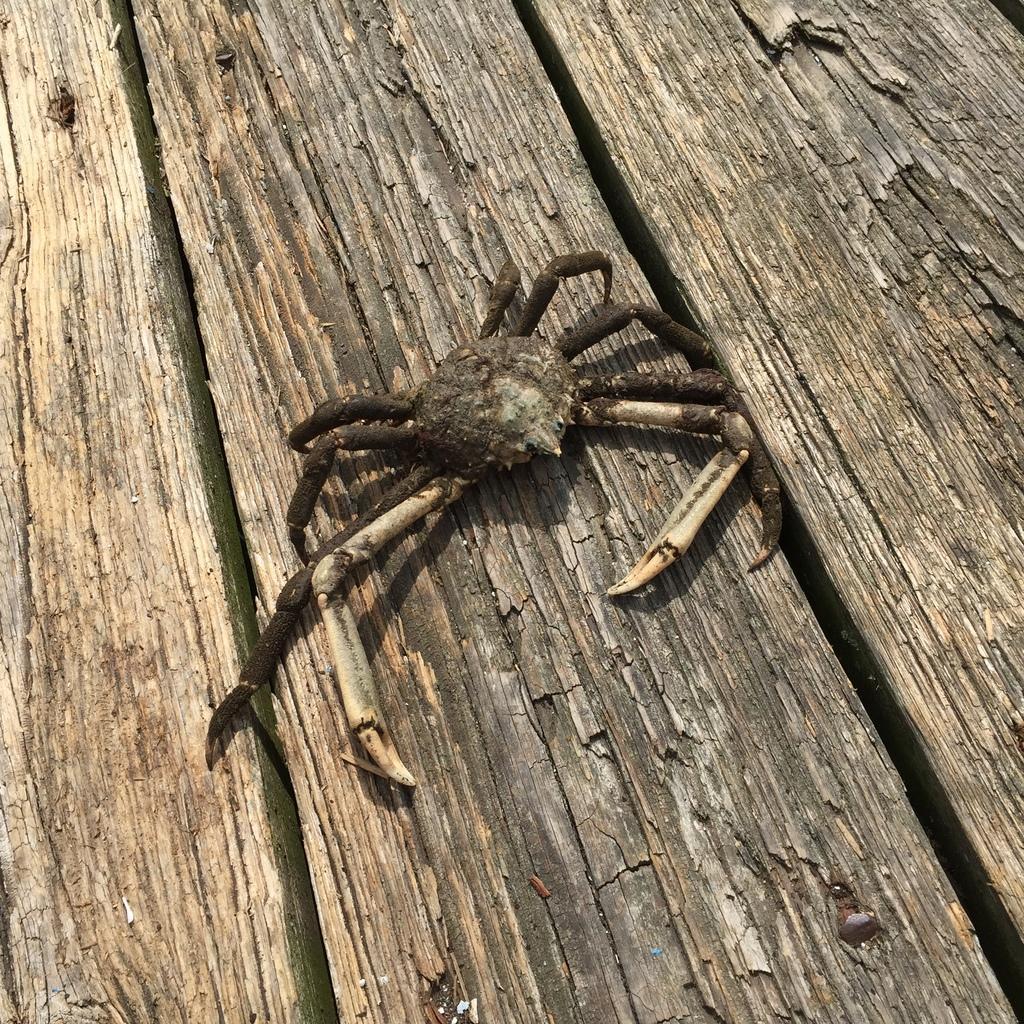Please provide a concise description of this image. In this picture I can see the crab on the wooden surface. 